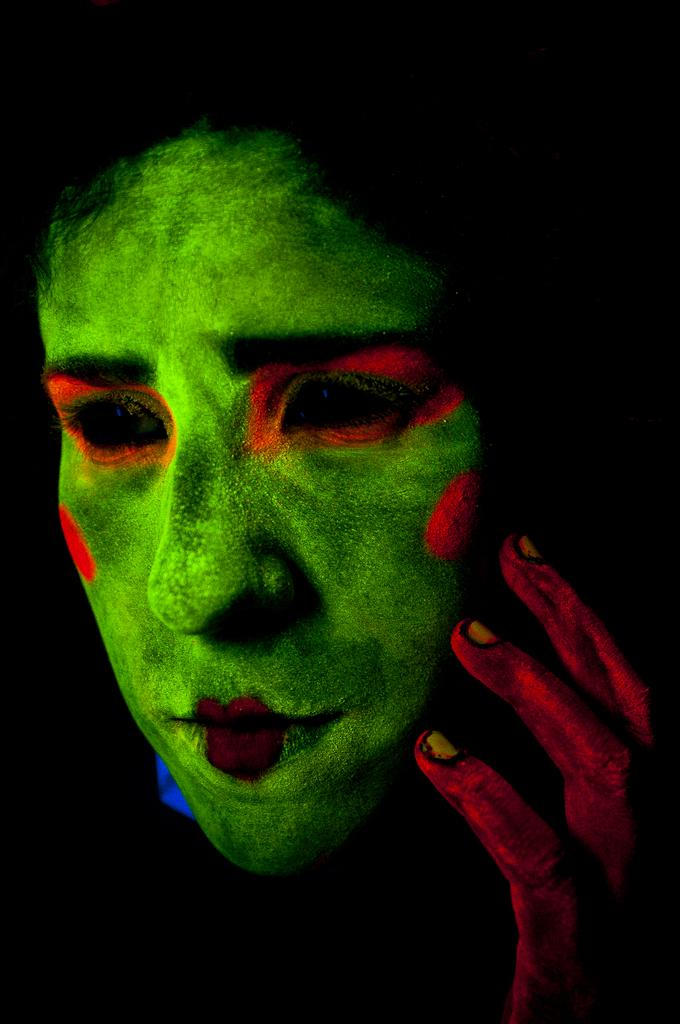What part of a person is shown in the image? There is a person's face in the image. What else of the person can be seen in the image? The person's hand is visible in the image. Can you describe the background of the image? The background of the image is dark. How many rings are on the cushion in the image? There are no rings or cushions present in the image. 